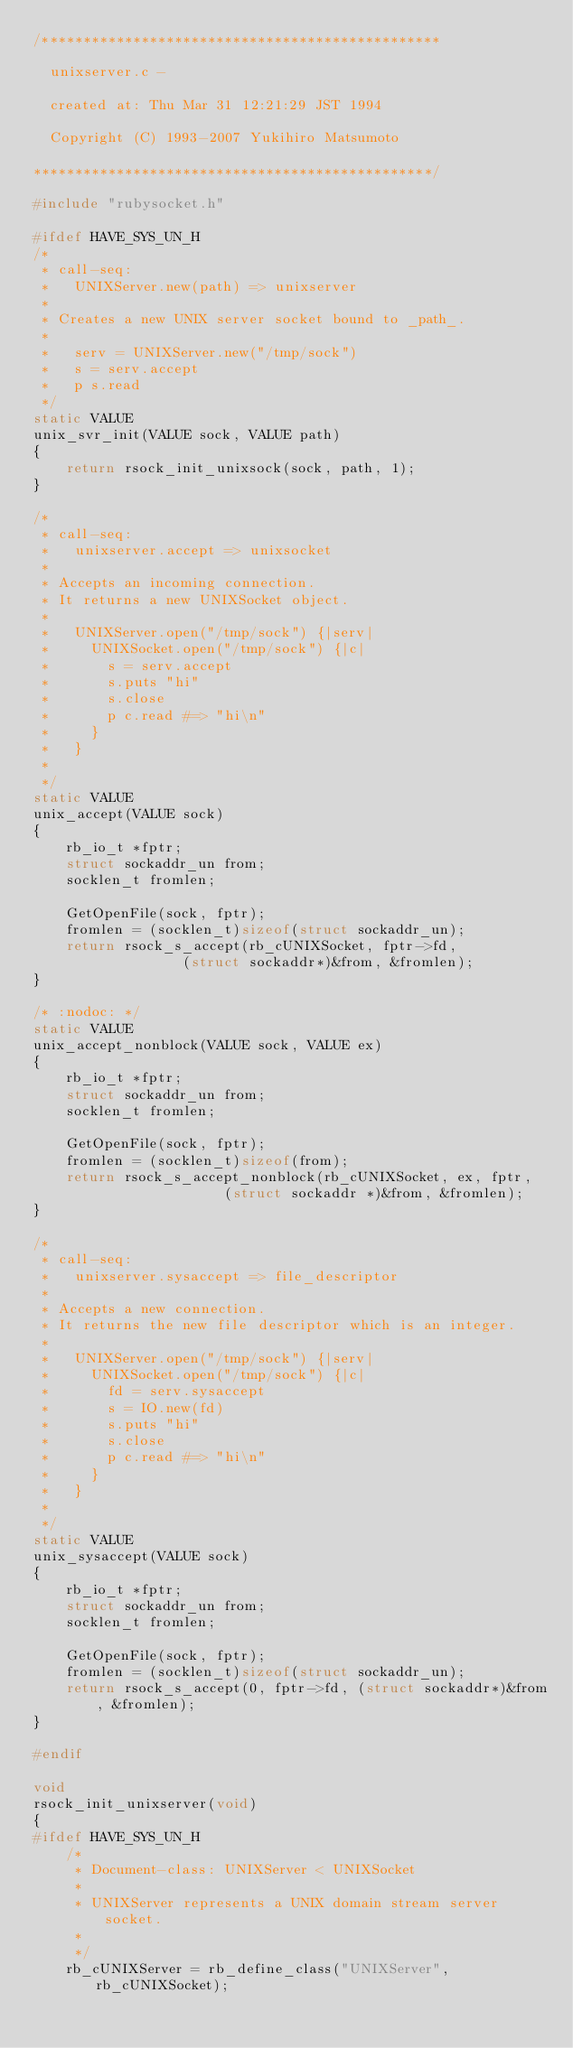<code> <loc_0><loc_0><loc_500><loc_500><_C_>/************************************************

  unixserver.c -

  created at: Thu Mar 31 12:21:29 JST 1994

  Copyright (C) 1993-2007 Yukihiro Matsumoto

************************************************/

#include "rubysocket.h"

#ifdef HAVE_SYS_UN_H
/*
 * call-seq:
 *   UNIXServer.new(path) => unixserver
 *
 * Creates a new UNIX server socket bound to _path_.
 *
 *   serv = UNIXServer.new("/tmp/sock")
 *   s = serv.accept
 *   p s.read
 */
static VALUE
unix_svr_init(VALUE sock, VALUE path)
{
    return rsock_init_unixsock(sock, path, 1);
}

/*
 * call-seq:
 *   unixserver.accept => unixsocket
 *
 * Accepts an incoming connection.
 * It returns a new UNIXSocket object.
 *
 *   UNIXServer.open("/tmp/sock") {|serv|
 *     UNIXSocket.open("/tmp/sock") {|c|
 *       s = serv.accept
 *       s.puts "hi"
 *       s.close
 *       p c.read #=> "hi\n"
 *     }
 *   }
 *
 */
static VALUE
unix_accept(VALUE sock)
{
    rb_io_t *fptr;
    struct sockaddr_un from;
    socklen_t fromlen;

    GetOpenFile(sock, fptr);
    fromlen = (socklen_t)sizeof(struct sockaddr_un);
    return rsock_s_accept(rb_cUNIXSocket, fptr->fd,
		          (struct sockaddr*)&from, &fromlen);
}

/* :nodoc: */
static VALUE
unix_accept_nonblock(VALUE sock, VALUE ex)
{
    rb_io_t *fptr;
    struct sockaddr_un from;
    socklen_t fromlen;

    GetOpenFile(sock, fptr);
    fromlen = (socklen_t)sizeof(from);
    return rsock_s_accept_nonblock(rb_cUNIXSocket, ex, fptr,
			           (struct sockaddr *)&from, &fromlen);
}

/*
 * call-seq:
 *   unixserver.sysaccept => file_descriptor
 *
 * Accepts a new connection.
 * It returns the new file descriptor which is an integer.
 *
 *   UNIXServer.open("/tmp/sock") {|serv|
 *     UNIXSocket.open("/tmp/sock") {|c|
 *       fd = serv.sysaccept
 *       s = IO.new(fd)
 *       s.puts "hi"
 *       s.close
 *       p c.read #=> "hi\n"
 *     }
 *   }
 *
 */
static VALUE
unix_sysaccept(VALUE sock)
{
    rb_io_t *fptr;
    struct sockaddr_un from;
    socklen_t fromlen;

    GetOpenFile(sock, fptr);
    fromlen = (socklen_t)sizeof(struct sockaddr_un);
    return rsock_s_accept(0, fptr->fd, (struct sockaddr*)&from, &fromlen);
}

#endif

void
rsock_init_unixserver(void)
{
#ifdef HAVE_SYS_UN_H
    /*
     * Document-class: UNIXServer < UNIXSocket
     *
     * UNIXServer represents a UNIX domain stream server socket.
     *
     */
    rb_cUNIXServer = rb_define_class("UNIXServer", rb_cUNIXSocket);</code> 